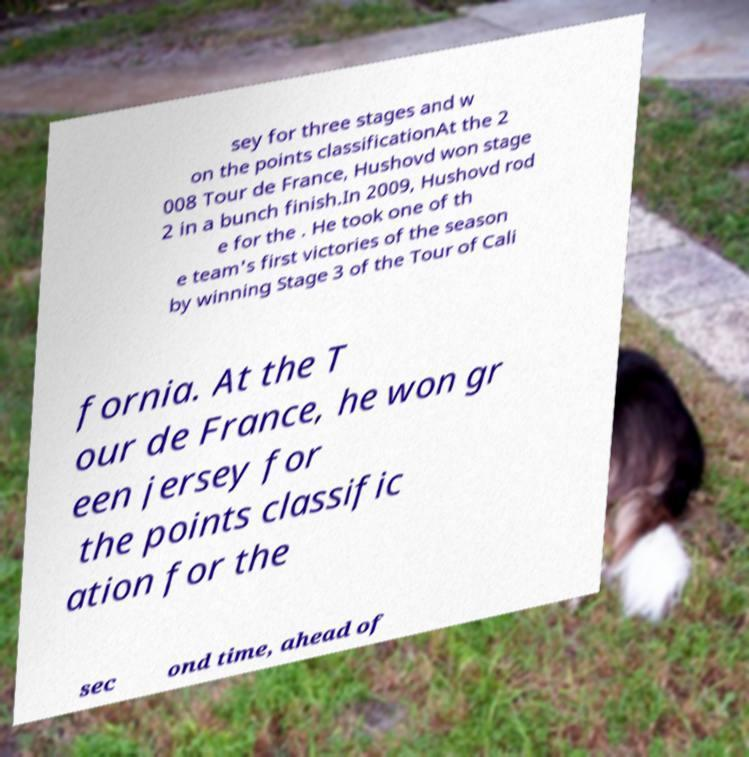Can you read and provide the text displayed in the image?This photo seems to have some interesting text. Can you extract and type it out for me? sey for three stages and w on the points classificationAt the 2 008 Tour de France, Hushovd won stage 2 in a bunch finish.In 2009, Hushovd rod e for the . He took one of th e team's first victories of the season by winning Stage 3 of the Tour of Cali fornia. At the T our de France, he won gr een jersey for the points classific ation for the sec ond time, ahead of 